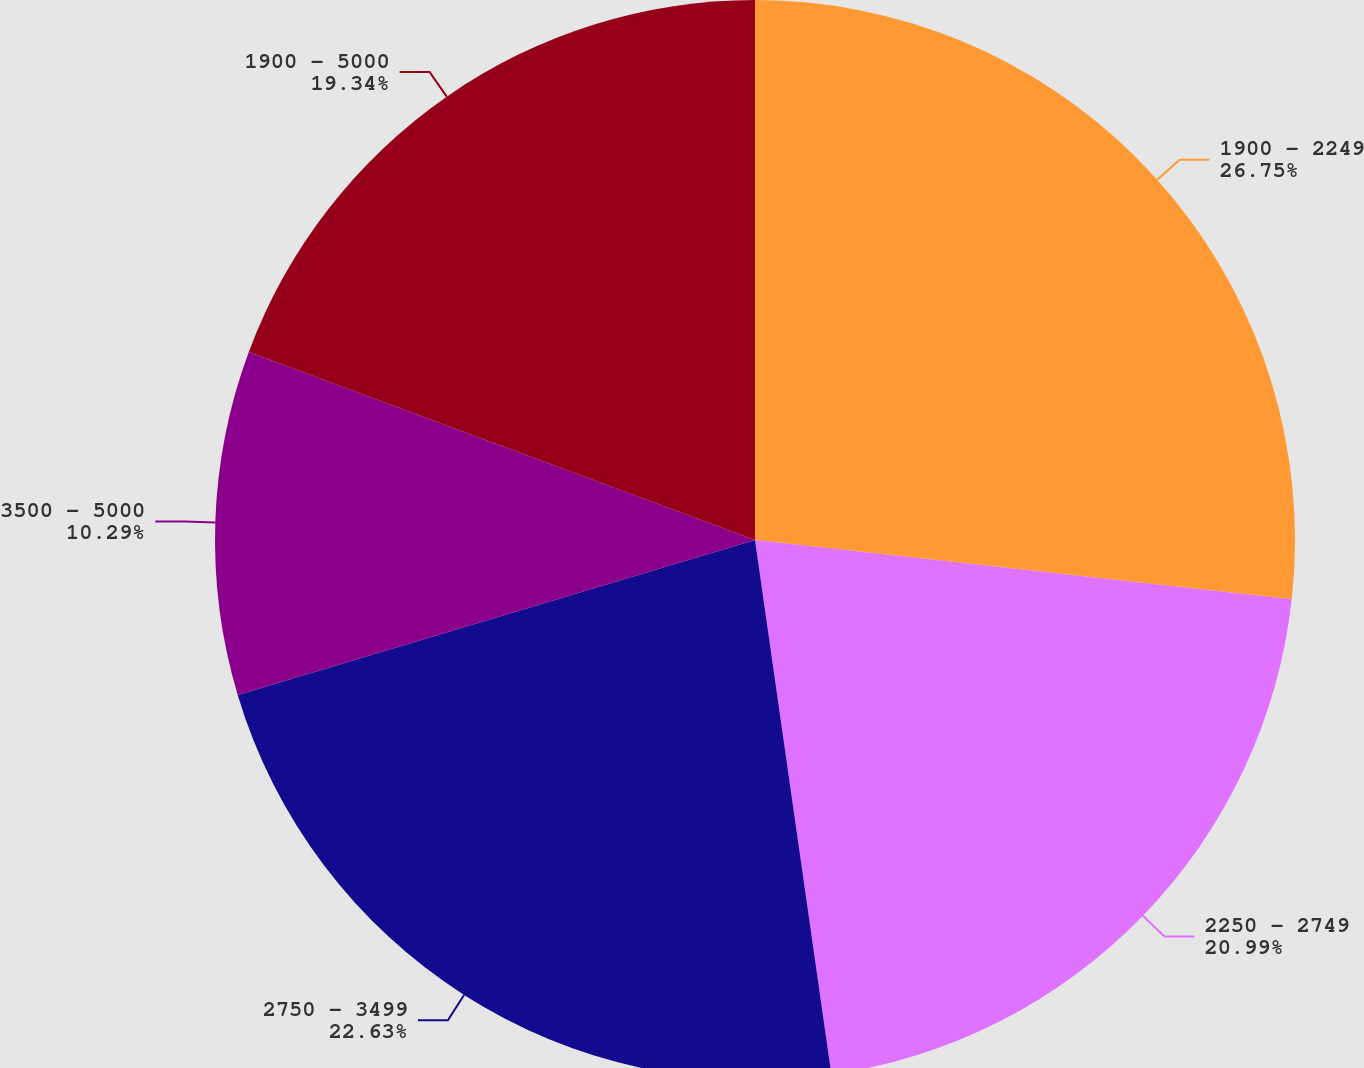Convert chart to OTSL. <chart><loc_0><loc_0><loc_500><loc_500><pie_chart><fcel>1900 - 2249<fcel>2250 - 2749<fcel>2750 - 3499<fcel>3500 - 5000<fcel>1900 - 5000<nl><fcel>26.75%<fcel>20.99%<fcel>22.63%<fcel>10.29%<fcel>19.34%<nl></chart> 